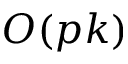<formula> <loc_0><loc_0><loc_500><loc_500>O ( p k )</formula> 